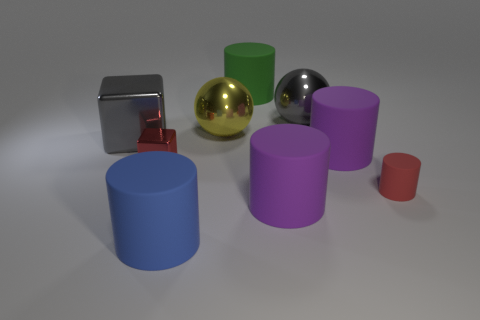Subtract all red cylinders. How many cylinders are left? 4 Subtract all yellow balls. How many balls are left? 1 Subtract all cubes. How many objects are left? 7 Add 1 small rubber cylinders. How many objects exist? 10 Subtract 1 spheres. How many spheres are left? 1 Subtract all cyan blocks. How many red cylinders are left? 1 Subtract 1 blue cylinders. How many objects are left? 8 Subtract all gray balls. Subtract all yellow cylinders. How many balls are left? 1 Subtract all small red metal things. Subtract all metal things. How many objects are left? 4 Add 2 yellow things. How many yellow things are left? 3 